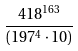<formula> <loc_0><loc_0><loc_500><loc_500>\frac { 4 1 8 ^ { 1 6 3 } } { ( 1 9 7 ^ { 4 } \cdot 1 0 ) }</formula> 